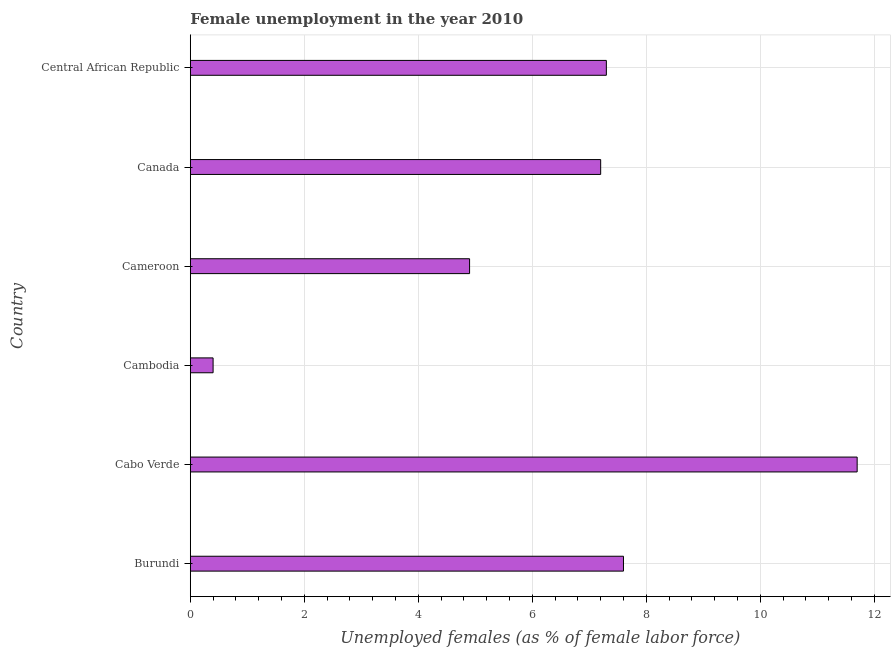Does the graph contain any zero values?
Your answer should be very brief. No. Does the graph contain grids?
Keep it short and to the point. Yes. What is the title of the graph?
Your response must be concise. Female unemployment in the year 2010. What is the label or title of the X-axis?
Keep it short and to the point. Unemployed females (as % of female labor force). What is the unemployed females population in Central African Republic?
Offer a very short reply. 7.3. Across all countries, what is the maximum unemployed females population?
Keep it short and to the point. 11.7. Across all countries, what is the minimum unemployed females population?
Make the answer very short. 0.4. In which country was the unemployed females population maximum?
Give a very brief answer. Cabo Verde. In which country was the unemployed females population minimum?
Provide a succinct answer. Cambodia. What is the sum of the unemployed females population?
Ensure brevity in your answer.  39.1. What is the difference between the unemployed females population in Cabo Verde and Cameroon?
Keep it short and to the point. 6.8. What is the average unemployed females population per country?
Provide a succinct answer. 6.52. What is the median unemployed females population?
Keep it short and to the point. 7.25. In how many countries, is the unemployed females population greater than 8 %?
Provide a succinct answer. 1. What is the ratio of the unemployed females population in Burundi to that in Canada?
Provide a short and direct response. 1.06. What is the difference between the highest and the second highest unemployed females population?
Make the answer very short. 4.1. Is the sum of the unemployed females population in Burundi and Cambodia greater than the maximum unemployed females population across all countries?
Make the answer very short. No. What is the difference between the highest and the lowest unemployed females population?
Give a very brief answer. 11.3. How many bars are there?
Keep it short and to the point. 6. Are all the bars in the graph horizontal?
Your response must be concise. Yes. How many countries are there in the graph?
Keep it short and to the point. 6. What is the difference between two consecutive major ticks on the X-axis?
Your response must be concise. 2. Are the values on the major ticks of X-axis written in scientific E-notation?
Keep it short and to the point. No. What is the Unemployed females (as % of female labor force) in Burundi?
Your answer should be very brief. 7.6. What is the Unemployed females (as % of female labor force) in Cabo Verde?
Offer a very short reply. 11.7. What is the Unemployed females (as % of female labor force) in Cambodia?
Offer a very short reply. 0.4. What is the Unemployed females (as % of female labor force) of Cameroon?
Your answer should be compact. 4.9. What is the Unemployed females (as % of female labor force) in Canada?
Give a very brief answer. 7.2. What is the Unemployed females (as % of female labor force) in Central African Republic?
Keep it short and to the point. 7.3. What is the difference between the Unemployed females (as % of female labor force) in Burundi and Cameroon?
Offer a very short reply. 2.7. What is the difference between the Unemployed females (as % of female labor force) in Burundi and Canada?
Your response must be concise. 0.4. What is the difference between the Unemployed females (as % of female labor force) in Cabo Verde and Cameroon?
Your answer should be very brief. 6.8. What is the difference between the Unemployed females (as % of female labor force) in Cabo Verde and Canada?
Give a very brief answer. 4.5. What is the difference between the Unemployed females (as % of female labor force) in Cabo Verde and Central African Republic?
Your answer should be very brief. 4.4. What is the difference between the Unemployed females (as % of female labor force) in Cambodia and Canada?
Make the answer very short. -6.8. What is the difference between the Unemployed females (as % of female labor force) in Cameroon and Canada?
Ensure brevity in your answer.  -2.3. What is the ratio of the Unemployed females (as % of female labor force) in Burundi to that in Cabo Verde?
Ensure brevity in your answer.  0.65. What is the ratio of the Unemployed females (as % of female labor force) in Burundi to that in Cambodia?
Provide a succinct answer. 19. What is the ratio of the Unemployed females (as % of female labor force) in Burundi to that in Cameroon?
Your response must be concise. 1.55. What is the ratio of the Unemployed females (as % of female labor force) in Burundi to that in Canada?
Your response must be concise. 1.06. What is the ratio of the Unemployed females (as % of female labor force) in Burundi to that in Central African Republic?
Your response must be concise. 1.04. What is the ratio of the Unemployed females (as % of female labor force) in Cabo Verde to that in Cambodia?
Ensure brevity in your answer.  29.25. What is the ratio of the Unemployed females (as % of female labor force) in Cabo Verde to that in Cameroon?
Your answer should be compact. 2.39. What is the ratio of the Unemployed females (as % of female labor force) in Cabo Verde to that in Canada?
Make the answer very short. 1.62. What is the ratio of the Unemployed females (as % of female labor force) in Cabo Verde to that in Central African Republic?
Your answer should be compact. 1.6. What is the ratio of the Unemployed females (as % of female labor force) in Cambodia to that in Cameroon?
Your answer should be very brief. 0.08. What is the ratio of the Unemployed females (as % of female labor force) in Cambodia to that in Canada?
Provide a short and direct response. 0.06. What is the ratio of the Unemployed females (as % of female labor force) in Cambodia to that in Central African Republic?
Your response must be concise. 0.06. What is the ratio of the Unemployed females (as % of female labor force) in Cameroon to that in Canada?
Your response must be concise. 0.68. What is the ratio of the Unemployed females (as % of female labor force) in Cameroon to that in Central African Republic?
Keep it short and to the point. 0.67. What is the ratio of the Unemployed females (as % of female labor force) in Canada to that in Central African Republic?
Provide a short and direct response. 0.99. 